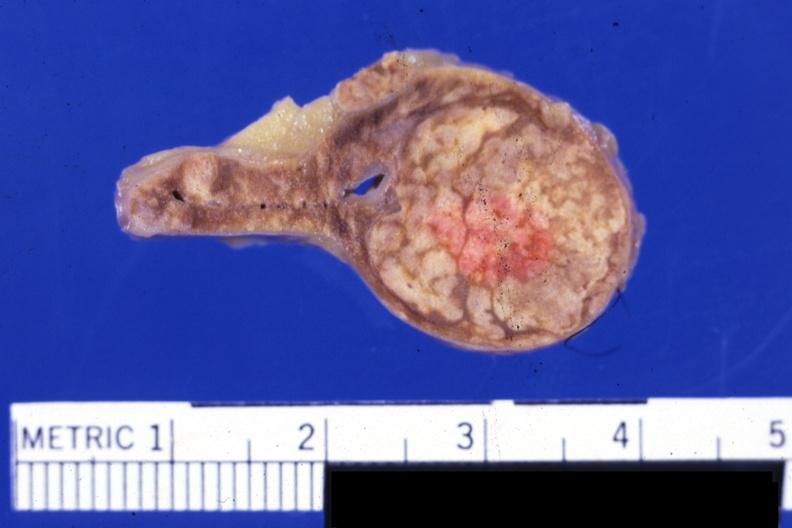what does this image show?
Answer the question using a single word or phrase. Fixed tissue but color not bad typical lesion 